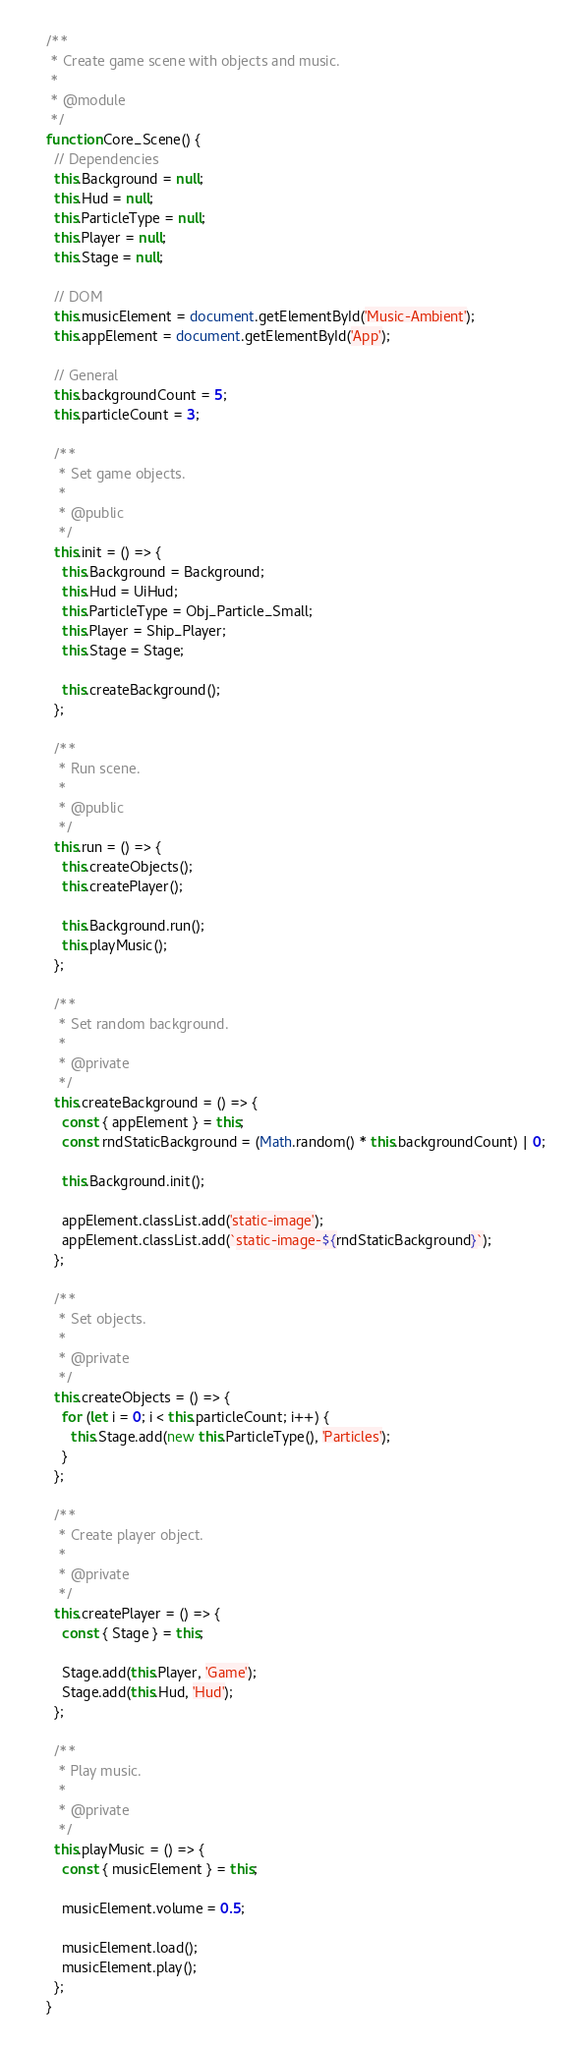Convert code to text. <code><loc_0><loc_0><loc_500><loc_500><_JavaScript_>/**
 * Create game scene with objects and music.
 *
 * @module
 */
function Core_Scene() {
  // Dependencies
  this.Background = null;
  this.Hud = null;
  this.ParticleType = null;
  this.Player = null;
  this.Stage = null;

  // DOM
  this.musicElement = document.getElementById('Music-Ambient');
  this.appElement = document.getElementById('App');

  // General
  this.backgroundCount = 5;
  this.particleCount = 3;

  /**
   * Set game objects.
   *
   * @public
   */
  this.init = () => {
    this.Background = Background;
    this.Hud = UiHud;
    this.ParticleType = Obj_Particle_Small;
    this.Player = Ship_Player;
    this.Stage = Stage;

    this.createBackground();
  };

  /**
   * Run scene.
   *
   * @public
   */
  this.run = () => {
    this.createObjects();
    this.createPlayer();

    this.Background.run();
    this.playMusic();
  };

  /**
   * Set random background.
   *
   * @private
   */
  this.createBackground = () => {
    const { appElement } = this;
    const rndStaticBackground = (Math.random() * this.backgroundCount) | 0;

    this.Background.init();

    appElement.classList.add('static-image');
    appElement.classList.add(`static-image-${rndStaticBackground}`);
  };

  /**
   * Set objects.
   *
   * @private
   */
  this.createObjects = () => {
    for (let i = 0; i < this.particleCount; i++) {
      this.Stage.add(new this.ParticleType(), 'Particles');
    }
  };

  /**
   * Create player object.
   *
   * @private
   */
  this.createPlayer = () => {
    const { Stage } = this;

    Stage.add(this.Player, 'Game');
    Stage.add(this.Hud, 'Hud');
  };

  /**
   * Play music.
   *
   * @private
   */
  this.playMusic = () => {
    const { musicElement } = this;

    musicElement.volume = 0.5;

    musicElement.load();
    musicElement.play();
  };
}
</code> 